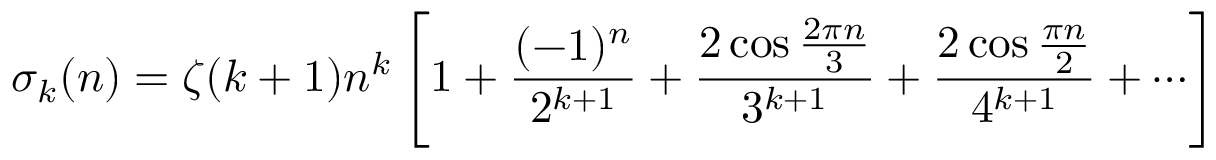Convert formula to latex. <formula><loc_0><loc_0><loc_500><loc_500>\sigma _ { k } ( n ) = \zeta ( k + 1 ) n ^ { k } \left [ 1 + { \frac { ( - 1 ) ^ { n } } { 2 ^ { k + 1 } } } + { \frac { 2 \cos { \frac { 2 \pi n } { 3 } } } { 3 ^ { k + 1 } } } + { \frac { 2 \cos { \frac { \pi n } { 2 } } } { 4 ^ { k + 1 } } } + \cdots \right ]</formula> 